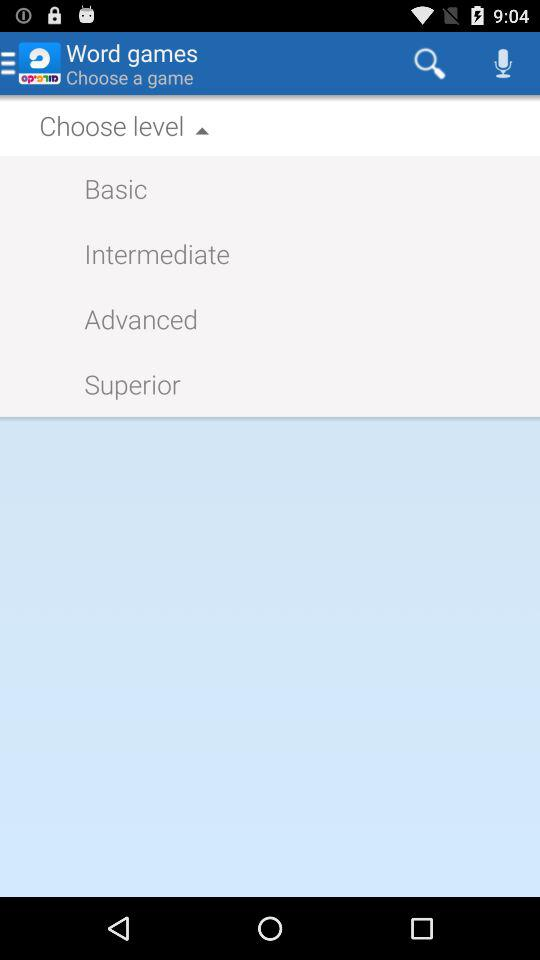How many levels are above basic?
Answer the question using a single word or phrase. 3 